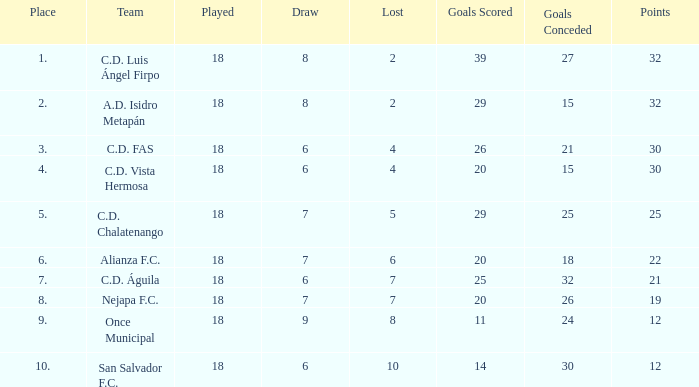I'm looking to parse the entire table for insights. Could you assist me with that? {'header': ['Place', 'Team', 'Played', 'Draw', 'Lost', 'Goals Scored', 'Goals Conceded', 'Points'], 'rows': [['1.', 'C.D. Luis Ángel Firpo', '18', '8', '2', '39', '27', '32'], ['2.', 'A.D. Isidro Metapán', '18', '8', '2', '29', '15', '32'], ['3.', 'C.D. FAS', '18', '6', '4', '26', '21', '30'], ['4.', 'C.D. Vista Hermosa', '18', '6', '4', '20', '15', '30'], ['5.', 'C.D. Chalatenango', '18', '7', '5', '29', '25', '25'], ['6.', 'Alianza F.C.', '18', '7', '6', '20', '18', '22'], ['7.', 'C.D. Águila', '18', '6', '7', '25', '32', '21'], ['8.', 'Nejapa F.C.', '18', '7', '7', '20', '26', '19'], ['9.', 'Once Municipal', '18', '9', '8', '11', '24', '12'], ['10.', 'San Salvador F.C.', '18', '6', '10', '14', '30', '12']]} What is the total number for a place with points smaller than 12? 0.0. 